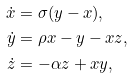<formula> <loc_0><loc_0><loc_500><loc_500>\dot { x } & = \sigma ( y - x ) , \\ \dot { y } & = \rho x - y - x z , \\ \dot { z } & = - \alpha z + x y ,</formula> 